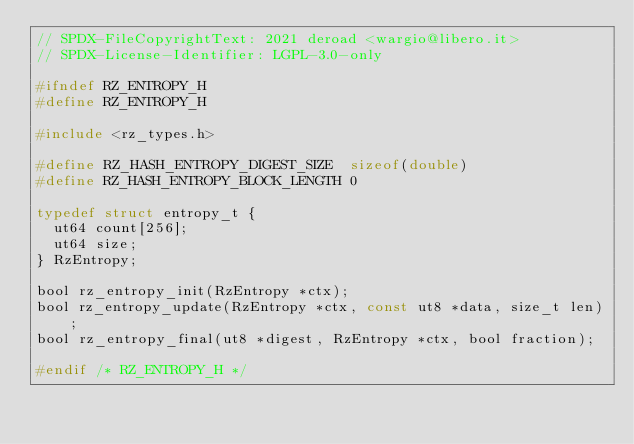Convert code to text. <code><loc_0><loc_0><loc_500><loc_500><_C_>// SPDX-FileCopyrightText: 2021 deroad <wargio@libero.it>
// SPDX-License-Identifier: LGPL-3.0-only

#ifndef RZ_ENTROPY_H
#define RZ_ENTROPY_H

#include <rz_types.h>

#define RZ_HASH_ENTROPY_DIGEST_SIZE  sizeof(double)
#define RZ_HASH_ENTROPY_BLOCK_LENGTH 0

typedef struct entropy_t {
	ut64 count[256];
	ut64 size;
} RzEntropy;

bool rz_entropy_init(RzEntropy *ctx);
bool rz_entropy_update(RzEntropy *ctx, const ut8 *data, size_t len);
bool rz_entropy_final(ut8 *digest, RzEntropy *ctx, bool fraction);

#endif /* RZ_ENTROPY_H */
</code> 